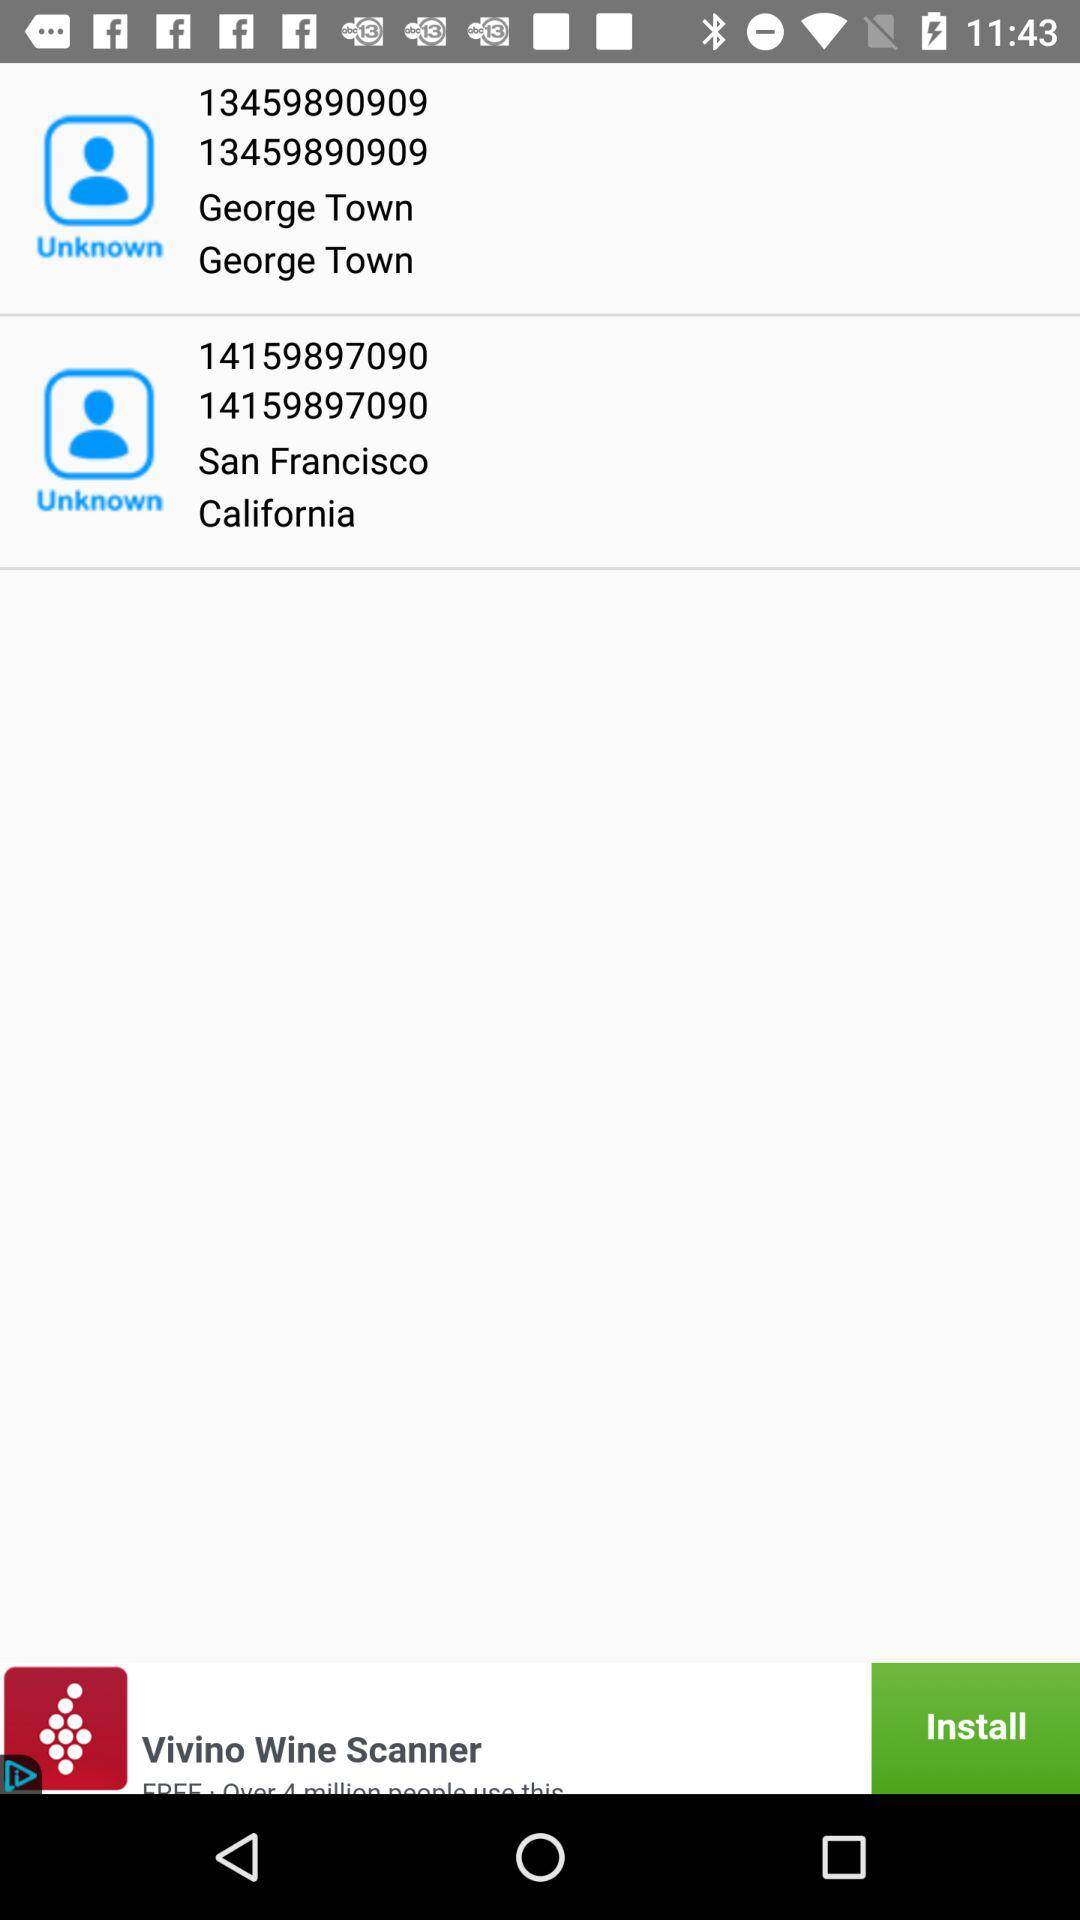What is the number from San Francisco, California? The numbers are 14159897090 and 14159897090. 